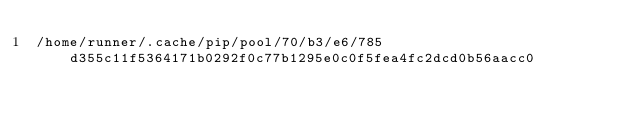Convert code to text. <code><loc_0><loc_0><loc_500><loc_500><_Cython_>/home/runner/.cache/pip/pool/70/b3/e6/785d355c11f5364171b0292f0c77b1295e0c0f5fea4fc2dcd0b56aacc0</code> 